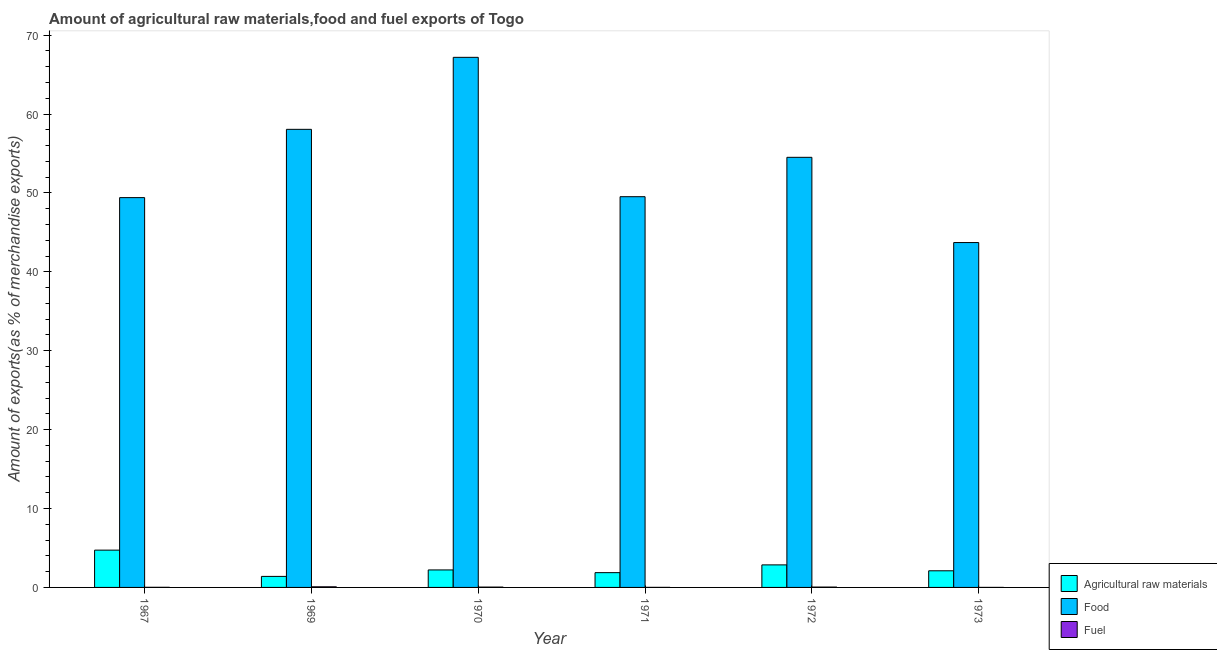How many different coloured bars are there?
Keep it short and to the point. 3. How many groups of bars are there?
Offer a very short reply. 6. How many bars are there on the 5th tick from the left?
Your answer should be compact. 3. What is the label of the 5th group of bars from the left?
Your answer should be very brief. 1972. What is the percentage of fuel exports in 1972?
Your response must be concise. 0.05. Across all years, what is the maximum percentage of fuel exports?
Your answer should be compact. 0.08. Across all years, what is the minimum percentage of fuel exports?
Make the answer very short. 0. In which year was the percentage of food exports maximum?
Your answer should be very brief. 1970. In which year was the percentage of food exports minimum?
Keep it short and to the point. 1973. What is the total percentage of raw materials exports in the graph?
Provide a short and direct response. 15.18. What is the difference between the percentage of fuel exports in 1969 and that in 1971?
Your response must be concise. 0.07. What is the difference between the percentage of food exports in 1972 and the percentage of raw materials exports in 1971?
Ensure brevity in your answer.  4.99. What is the average percentage of food exports per year?
Your answer should be compact. 53.74. In the year 1967, what is the difference between the percentage of food exports and percentage of fuel exports?
Ensure brevity in your answer.  0. What is the ratio of the percentage of fuel exports in 1967 to that in 1969?
Give a very brief answer. 0.2. Is the percentage of raw materials exports in 1970 less than that in 1973?
Give a very brief answer. No. Is the difference between the percentage of fuel exports in 1970 and 1972 greater than the difference between the percentage of food exports in 1970 and 1972?
Ensure brevity in your answer.  No. What is the difference between the highest and the second highest percentage of fuel exports?
Your answer should be very brief. 0.03. What is the difference between the highest and the lowest percentage of fuel exports?
Offer a very short reply. 0.07. Is the sum of the percentage of fuel exports in 1970 and 1973 greater than the maximum percentage of food exports across all years?
Offer a terse response. No. What does the 2nd bar from the left in 1970 represents?
Provide a succinct answer. Food. What does the 2nd bar from the right in 1967 represents?
Offer a terse response. Food. How many bars are there?
Your answer should be very brief. 18. What is the difference between two consecutive major ticks on the Y-axis?
Offer a very short reply. 10. Does the graph contain grids?
Provide a short and direct response. No. What is the title of the graph?
Make the answer very short. Amount of agricultural raw materials,food and fuel exports of Togo. Does "Wage workers" appear as one of the legend labels in the graph?
Make the answer very short. No. What is the label or title of the Y-axis?
Offer a terse response. Amount of exports(as % of merchandise exports). What is the Amount of exports(as % of merchandise exports) of Agricultural raw materials in 1967?
Offer a terse response. 4.73. What is the Amount of exports(as % of merchandise exports) of Food in 1967?
Provide a short and direct response. 49.41. What is the Amount of exports(as % of merchandise exports) in Fuel in 1967?
Provide a short and direct response. 0.02. What is the Amount of exports(as % of merchandise exports) of Agricultural raw materials in 1969?
Offer a terse response. 1.4. What is the Amount of exports(as % of merchandise exports) in Food in 1969?
Offer a terse response. 58.07. What is the Amount of exports(as % of merchandise exports) in Fuel in 1969?
Your answer should be very brief. 0.08. What is the Amount of exports(as % of merchandise exports) in Agricultural raw materials in 1970?
Give a very brief answer. 2.22. What is the Amount of exports(as % of merchandise exports) of Food in 1970?
Your response must be concise. 67.2. What is the Amount of exports(as % of merchandise exports) of Fuel in 1970?
Ensure brevity in your answer.  0.04. What is the Amount of exports(as % of merchandise exports) in Agricultural raw materials in 1971?
Ensure brevity in your answer.  1.87. What is the Amount of exports(as % of merchandise exports) in Food in 1971?
Provide a short and direct response. 49.53. What is the Amount of exports(as % of merchandise exports) of Fuel in 1971?
Provide a short and direct response. 0.01. What is the Amount of exports(as % of merchandise exports) of Agricultural raw materials in 1972?
Offer a terse response. 2.86. What is the Amount of exports(as % of merchandise exports) in Food in 1972?
Your answer should be very brief. 54.52. What is the Amount of exports(as % of merchandise exports) in Fuel in 1972?
Your response must be concise. 0.05. What is the Amount of exports(as % of merchandise exports) of Agricultural raw materials in 1973?
Your answer should be very brief. 2.11. What is the Amount of exports(as % of merchandise exports) of Food in 1973?
Your response must be concise. 43.72. What is the Amount of exports(as % of merchandise exports) of Fuel in 1973?
Your answer should be very brief. 0. Across all years, what is the maximum Amount of exports(as % of merchandise exports) of Agricultural raw materials?
Your answer should be very brief. 4.73. Across all years, what is the maximum Amount of exports(as % of merchandise exports) of Food?
Provide a succinct answer. 67.2. Across all years, what is the maximum Amount of exports(as % of merchandise exports) of Fuel?
Offer a very short reply. 0.08. Across all years, what is the minimum Amount of exports(as % of merchandise exports) of Agricultural raw materials?
Your response must be concise. 1.4. Across all years, what is the minimum Amount of exports(as % of merchandise exports) of Food?
Your answer should be compact. 43.72. Across all years, what is the minimum Amount of exports(as % of merchandise exports) of Fuel?
Your response must be concise. 0. What is the total Amount of exports(as % of merchandise exports) of Agricultural raw materials in the graph?
Provide a succinct answer. 15.18. What is the total Amount of exports(as % of merchandise exports) in Food in the graph?
Offer a terse response. 322.45. What is the total Amount of exports(as % of merchandise exports) in Fuel in the graph?
Provide a succinct answer. 0.19. What is the difference between the Amount of exports(as % of merchandise exports) of Agricultural raw materials in 1967 and that in 1969?
Ensure brevity in your answer.  3.33. What is the difference between the Amount of exports(as % of merchandise exports) in Food in 1967 and that in 1969?
Provide a short and direct response. -8.66. What is the difference between the Amount of exports(as % of merchandise exports) in Fuel in 1967 and that in 1969?
Offer a terse response. -0.06. What is the difference between the Amount of exports(as % of merchandise exports) in Agricultural raw materials in 1967 and that in 1970?
Your answer should be very brief. 2.51. What is the difference between the Amount of exports(as % of merchandise exports) of Food in 1967 and that in 1970?
Offer a terse response. -17.78. What is the difference between the Amount of exports(as % of merchandise exports) in Fuel in 1967 and that in 1970?
Offer a very short reply. -0.03. What is the difference between the Amount of exports(as % of merchandise exports) in Agricultural raw materials in 1967 and that in 1971?
Your answer should be very brief. 2.85. What is the difference between the Amount of exports(as % of merchandise exports) of Food in 1967 and that in 1971?
Provide a succinct answer. -0.12. What is the difference between the Amount of exports(as % of merchandise exports) in Fuel in 1967 and that in 1971?
Ensure brevity in your answer.  0.01. What is the difference between the Amount of exports(as % of merchandise exports) of Agricultural raw materials in 1967 and that in 1972?
Offer a terse response. 1.87. What is the difference between the Amount of exports(as % of merchandise exports) of Food in 1967 and that in 1972?
Keep it short and to the point. -5.11. What is the difference between the Amount of exports(as % of merchandise exports) in Fuel in 1967 and that in 1972?
Ensure brevity in your answer.  -0.03. What is the difference between the Amount of exports(as % of merchandise exports) of Agricultural raw materials in 1967 and that in 1973?
Your answer should be very brief. 2.62. What is the difference between the Amount of exports(as % of merchandise exports) of Food in 1967 and that in 1973?
Your answer should be very brief. 5.7. What is the difference between the Amount of exports(as % of merchandise exports) of Fuel in 1967 and that in 1973?
Give a very brief answer. 0.01. What is the difference between the Amount of exports(as % of merchandise exports) of Agricultural raw materials in 1969 and that in 1970?
Your response must be concise. -0.82. What is the difference between the Amount of exports(as % of merchandise exports) in Food in 1969 and that in 1970?
Give a very brief answer. -9.13. What is the difference between the Amount of exports(as % of merchandise exports) in Fuel in 1969 and that in 1970?
Provide a short and direct response. 0.04. What is the difference between the Amount of exports(as % of merchandise exports) of Agricultural raw materials in 1969 and that in 1971?
Provide a short and direct response. -0.48. What is the difference between the Amount of exports(as % of merchandise exports) in Food in 1969 and that in 1971?
Your answer should be very brief. 8.54. What is the difference between the Amount of exports(as % of merchandise exports) of Fuel in 1969 and that in 1971?
Keep it short and to the point. 0.07. What is the difference between the Amount of exports(as % of merchandise exports) in Agricultural raw materials in 1969 and that in 1972?
Keep it short and to the point. -1.46. What is the difference between the Amount of exports(as % of merchandise exports) in Food in 1969 and that in 1972?
Give a very brief answer. 3.55. What is the difference between the Amount of exports(as % of merchandise exports) of Fuel in 1969 and that in 1972?
Ensure brevity in your answer.  0.03. What is the difference between the Amount of exports(as % of merchandise exports) in Agricultural raw materials in 1969 and that in 1973?
Offer a very short reply. -0.71. What is the difference between the Amount of exports(as % of merchandise exports) in Food in 1969 and that in 1973?
Offer a very short reply. 14.35. What is the difference between the Amount of exports(as % of merchandise exports) in Fuel in 1969 and that in 1973?
Offer a very short reply. 0.07. What is the difference between the Amount of exports(as % of merchandise exports) of Agricultural raw materials in 1970 and that in 1971?
Make the answer very short. 0.34. What is the difference between the Amount of exports(as % of merchandise exports) of Food in 1970 and that in 1971?
Provide a succinct answer. 17.67. What is the difference between the Amount of exports(as % of merchandise exports) in Fuel in 1970 and that in 1971?
Provide a short and direct response. 0.03. What is the difference between the Amount of exports(as % of merchandise exports) of Agricultural raw materials in 1970 and that in 1972?
Make the answer very short. -0.64. What is the difference between the Amount of exports(as % of merchandise exports) in Food in 1970 and that in 1972?
Give a very brief answer. 12.68. What is the difference between the Amount of exports(as % of merchandise exports) of Fuel in 1970 and that in 1972?
Keep it short and to the point. -0. What is the difference between the Amount of exports(as % of merchandise exports) in Agricultural raw materials in 1970 and that in 1973?
Ensure brevity in your answer.  0.11. What is the difference between the Amount of exports(as % of merchandise exports) in Food in 1970 and that in 1973?
Provide a short and direct response. 23.48. What is the difference between the Amount of exports(as % of merchandise exports) of Fuel in 1970 and that in 1973?
Your answer should be compact. 0.04. What is the difference between the Amount of exports(as % of merchandise exports) of Agricultural raw materials in 1971 and that in 1972?
Offer a terse response. -0.98. What is the difference between the Amount of exports(as % of merchandise exports) in Food in 1971 and that in 1972?
Your answer should be very brief. -4.99. What is the difference between the Amount of exports(as % of merchandise exports) of Fuel in 1971 and that in 1972?
Make the answer very short. -0.04. What is the difference between the Amount of exports(as % of merchandise exports) of Agricultural raw materials in 1971 and that in 1973?
Your response must be concise. -0.24. What is the difference between the Amount of exports(as % of merchandise exports) in Food in 1971 and that in 1973?
Offer a very short reply. 5.81. What is the difference between the Amount of exports(as % of merchandise exports) in Fuel in 1971 and that in 1973?
Your answer should be very brief. 0. What is the difference between the Amount of exports(as % of merchandise exports) of Agricultural raw materials in 1972 and that in 1973?
Offer a very short reply. 0.75. What is the difference between the Amount of exports(as % of merchandise exports) of Food in 1972 and that in 1973?
Offer a terse response. 10.8. What is the difference between the Amount of exports(as % of merchandise exports) of Fuel in 1972 and that in 1973?
Provide a succinct answer. 0.04. What is the difference between the Amount of exports(as % of merchandise exports) of Agricultural raw materials in 1967 and the Amount of exports(as % of merchandise exports) of Food in 1969?
Your answer should be very brief. -53.34. What is the difference between the Amount of exports(as % of merchandise exports) of Agricultural raw materials in 1967 and the Amount of exports(as % of merchandise exports) of Fuel in 1969?
Your answer should be compact. 4.65. What is the difference between the Amount of exports(as % of merchandise exports) of Food in 1967 and the Amount of exports(as % of merchandise exports) of Fuel in 1969?
Your response must be concise. 49.33. What is the difference between the Amount of exports(as % of merchandise exports) in Agricultural raw materials in 1967 and the Amount of exports(as % of merchandise exports) in Food in 1970?
Keep it short and to the point. -62.47. What is the difference between the Amount of exports(as % of merchandise exports) of Agricultural raw materials in 1967 and the Amount of exports(as % of merchandise exports) of Fuel in 1970?
Provide a succinct answer. 4.68. What is the difference between the Amount of exports(as % of merchandise exports) of Food in 1967 and the Amount of exports(as % of merchandise exports) of Fuel in 1970?
Make the answer very short. 49.37. What is the difference between the Amount of exports(as % of merchandise exports) in Agricultural raw materials in 1967 and the Amount of exports(as % of merchandise exports) in Food in 1971?
Your response must be concise. -44.8. What is the difference between the Amount of exports(as % of merchandise exports) in Agricultural raw materials in 1967 and the Amount of exports(as % of merchandise exports) in Fuel in 1971?
Offer a terse response. 4.72. What is the difference between the Amount of exports(as % of merchandise exports) of Food in 1967 and the Amount of exports(as % of merchandise exports) of Fuel in 1971?
Offer a very short reply. 49.41. What is the difference between the Amount of exports(as % of merchandise exports) in Agricultural raw materials in 1967 and the Amount of exports(as % of merchandise exports) in Food in 1972?
Offer a terse response. -49.79. What is the difference between the Amount of exports(as % of merchandise exports) of Agricultural raw materials in 1967 and the Amount of exports(as % of merchandise exports) of Fuel in 1972?
Offer a very short reply. 4.68. What is the difference between the Amount of exports(as % of merchandise exports) in Food in 1967 and the Amount of exports(as % of merchandise exports) in Fuel in 1972?
Offer a very short reply. 49.37. What is the difference between the Amount of exports(as % of merchandise exports) in Agricultural raw materials in 1967 and the Amount of exports(as % of merchandise exports) in Food in 1973?
Make the answer very short. -38.99. What is the difference between the Amount of exports(as % of merchandise exports) in Agricultural raw materials in 1967 and the Amount of exports(as % of merchandise exports) in Fuel in 1973?
Your answer should be very brief. 4.72. What is the difference between the Amount of exports(as % of merchandise exports) of Food in 1967 and the Amount of exports(as % of merchandise exports) of Fuel in 1973?
Your answer should be compact. 49.41. What is the difference between the Amount of exports(as % of merchandise exports) of Agricultural raw materials in 1969 and the Amount of exports(as % of merchandise exports) of Food in 1970?
Provide a short and direct response. -65.8. What is the difference between the Amount of exports(as % of merchandise exports) of Agricultural raw materials in 1969 and the Amount of exports(as % of merchandise exports) of Fuel in 1970?
Make the answer very short. 1.35. What is the difference between the Amount of exports(as % of merchandise exports) in Food in 1969 and the Amount of exports(as % of merchandise exports) in Fuel in 1970?
Make the answer very short. 58.03. What is the difference between the Amount of exports(as % of merchandise exports) in Agricultural raw materials in 1969 and the Amount of exports(as % of merchandise exports) in Food in 1971?
Keep it short and to the point. -48.13. What is the difference between the Amount of exports(as % of merchandise exports) of Agricultural raw materials in 1969 and the Amount of exports(as % of merchandise exports) of Fuel in 1971?
Your answer should be compact. 1.39. What is the difference between the Amount of exports(as % of merchandise exports) in Food in 1969 and the Amount of exports(as % of merchandise exports) in Fuel in 1971?
Your response must be concise. 58.06. What is the difference between the Amount of exports(as % of merchandise exports) in Agricultural raw materials in 1969 and the Amount of exports(as % of merchandise exports) in Food in 1972?
Your answer should be compact. -53.12. What is the difference between the Amount of exports(as % of merchandise exports) of Agricultural raw materials in 1969 and the Amount of exports(as % of merchandise exports) of Fuel in 1972?
Offer a terse response. 1.35. What is the difference between the Amount of exports(as % of merchandise exports) in Food in 1969 and the Amount of exports(as % of merchandise exports) in Fuel in 1972?
Provide a succinct answer. 58.02. What is the difference between the Amount of exports(as % of merchandise exports) of Agricultural raw materials in 1969 and the Amount of exports(as % of merchandise exports) of Food in 1973?
Offer a very short reply. -42.32. What is the difference between the Amount of exports(as % of merchandise exports) in Agricultural raw materials in 1969 and the Amount of exports(as % of merchandise exports) in Fuel in 1973?
Keep it short and to the point. 1.39. What is the difference between the Amount of exports(as % of merchandise exports) of Food in 1969 and the Amount of exports(as % of merchandise exports) of Fuel in 1973?
Make the answer very short. 58.07. What is the difference between the Amount of exports(as % of merchandise exports) of Agricultural raw materials in 1970 and the Amount of exports(as % of merchandise exports) of Food in 1971?
Your answer should be compact. -47.31. What is the difference between the Amount of exports(as % of merchandise exports) of Agricultural raw materials in 1970 and the Amount of exports(as % of merchandise exports) of Fuel in 1971?
Keep it short and to the point. 2.21. What is the difference between the Amount of exports(as % of merchandise exports) of Food in 1970 and the Amount of exports(as % of merchandise exports) of Fuel in 1971?
Provide a succinct answer. 67.19. What is the difference between the Amount of exports(as % of merchandise exports) of Agricultural raw materials in 1970 and the Amount of exports(as % of merchandise exports) of Food in 1972?
Give a very brief answer. -52.3. What is the difference between the Amount of exports(as % of merchandise exports) of Agricultural raw materials in 1970 and the Amount of exports(as % of merchandise exports) of Fuel in 1972?
Keep it short and to the point. 2.17. What is the difference between the Amount of exports(as % of merchandise exports) of Food in 1970 and the Amount of exports(as % of merchandise exports) of Fuel in 1972?
Ensure brevity in your answer.  67.15. What is the difference between the Amount of exports(as % of merchandise exports) in Agricultural raw materials in 1970 and the Amount of exports(as % of merchandise exports) in Food in 1973?
Provide a succinct answer. -41.5. What is the difference between the Amount of exports(as % of merchandise exports) in Agricultural raw materials in 1970 and the Amount of exports(as % of merchandise exports) in Fuel in 1973?
Keep it short and to the point. 2.21. What is the difference between the Amount of exports(as % of merchandise exports) in Food in 1970 and the Amount of exports(as % of merchandise exports) in Fuel in 1973?
Ensure brevity in your answer.  67.19. What is the difference between the Amount of exports(as % of merchandise exports) of Agricultural raw materials in 1971 and the Amount of exports(as % of merchandise exports) of Food in 1972?
Offer a terse response. -52.65. What is the difference between the Amount of exports(as % of merchandise exports) in Agricultural raw materials in 1971 and the Amount of exports(as % of merchandise exports) in Fuel in 1972?
Make the answer very short. 1.83. What is the difference between the Amount of exports(as % of merchandise exports) in Food in 1971 and the Amount of exports(as % of merchandise exports) in Fuel in 1972?
Offer a terse response. 49.49. What is the difference between the Amount of exports(as % of merchandise exports) in Agricultural raw materials in 1971 and the Amount of exports(as % of merchandise exports) in Food in 1973?
Offer a very short reply. -41.84. What is the difference between the Amount of exports(as % of merchandise exports) in Agricultural raw materials in 1971 and the Amount of exports(as % of merchandise exports) in Fuel in 1973?
Make the answer very short. 1.87. What is the difference between the Amount of exports(as % of merchandise exports) of Food in 1971 and the Amount of exports(as % of merchandise exports) of Fuel in 1973?
Give a very brief answer. 49.53. What is the difference between the Amount of exports(as % of merchandise exports) in Agricultural raw materials in 1972 and the Amount of exports(as % of merchandise exports) in Food in 1973?
Make the answer very short. -40.86. What is the difference between the Amount of exports(as % of merchandise exports) in Agricultural raw materials in 1972 and the Amount of exports(as % of merchandise exports) in Fuel in 1973?
Your answer should be very brief. 2.85. What is the difference between the Amount of exports(as % of merchandise exports) of Food in 1972 and the Amount of exports(as % of merchandise exports) of Fuel in 1973?
Provide a short and direct response. 54.52. What is the average Amount of exports(as % of merchandise exports) of Agricultural raw materials per year?
Provide a succinct answer. 2.53. What is the average Amount of exports(as % of merchandise exports) in Food per year?
Your answer should be compact. 53.74. What is the average Amount of exports(as % of merchandise exports) of Fuel per year?
Your response must be concise. 0.03. In the year 1967, what is the difference between the Amount of exports(as % of merchandise exports) in Agricultural raw materials and Amount of exports(as % of merchandise exports) in Food?
Your answer should be very brief. -44.69. In the year 1967, what is the difference between the Amount of exports(as % of merchandise exports) of Agricultural raw materials and Amount of exports(as % of merchandise exports) of Fuel?
Offer a terse response. 4.71. In the year 1967, what is the difference between the Amount of exports(as % of merchandise exports) in Food and Amount of exports(as % of merchandise exports) in Fuel?
Provide a short and direct response. 49.4. In the year 1969, what is the difference between the Amount of exports(as % of merchandise exports) of Agricultural raw materials and Amount of exports(as % of merchandise exports) of Food?
Provide a succinct answer. -56.67. In the year 1969, what is the difference between the Amount of exports(as % of merchandise exports) in Agricultural raw materials and Amount of exports(as % of merchandise exports) in Fuel?
Provide a short and direct response. 1.32. In the year 1969, what is the difference between the Amount of exports(as % of merchandise exports) in Food and Amount of exports(as % of merchandise exports) in Fuel?
Make the answer very short. 57.99. In the year 1970, what is the difference between the Amount of exports(as % of merchandise exports) of Agricultural raw materials and Amount of exports(as % of merchandise exports) of Food?
Your answer should be compact. -64.98. In the year 1970, what is the difference between the Amount of exports(as % of merchandise exports) in Agricultural raw materials and Amount of exports(as % of merchandise exports) in Fuel?
Provide a succinct answer. 2.18. In the year 1970, what is the difference between the Amount of exports(as % of merchandise exports) of Food and Amount of exports(as % of merchandise exports) of Fuel?
Provide a short and direct response. 67.15. In the year 1971, what is the difference between the Amount of exports(as % of merchandise exports) of Agricultural raw materials and Amount of exports(as % of merchandise exports) of Food?
Offer a terse response. -47.66. In the year 1971, what is the difference between the Amount of exports(as % of merchandise exports) in Agricultural raw materials and Amount of exports(as % of merchandise exports) in Fuel?
Provide a short and direct response. 1.87. In the year 1971, what is the difference between the Amount of exports(as % of merchandise exports) of Food and Amount of exports(as % of merchandise exports) of Fuel?
Ensure brevity in your answer.  49.52. In the year 1972, what is the difference between the Amount of exports(as % of merchandise exports) of Agricultural raw materials and Amount of exports(as % of merchandise exports) of Food?
Keep it short and to the point. -51.66. In the year 1972, what is the difference between the Amount of exports(as % of merchandise exports) in Agricultural raw materials and Amount of exports(as % of merchandise exports) in Fuel?
Give a very brief answer. 2.81. In the year 1972, what is the difference between the Amount of exports(as % of merchandise exports) of Food and Amount of exports(as % of merchandise exports) of Fuel?
Provide a succinct answer. 54.48. In the year 1973, what is the difference between the Amount of exports(as % of merchandise exports) of Agricultural raw materials and Amount of exports(as % of merchandise exports) of Food?
Keep it short and to the point. -41.61. In the year 1973, what is the difference between the Amount of exports(as % of merchandise exports) in Agricultural raw materials and Amount of exports(as % of merchandise exports) in Fuel?
Offer a terse response. 2.1. In the year 1973, what is the difference between the Amount of exports(as % of merchandise exports) of Food and Amount of exports(as % of merchandise exports) of Fuel?
Your answer should be very brief. 43.71. What is the ratio of the Amount of exports(as % of merchandise exports) of Agricultural raw materials in 1967 to that in 1969?
Provide a short and direct response. 3.38. What is the ratio of the Amount of exports(as % of merchandise exports) of Food in 1967 to that in 1969?
Offer a very short reply. 0.85. What is the ratio of the Amount of exports(as % of merchandise exports) in Fuel in 1967 to that in 1969?
Your answer should be compact. 0.2. What is the ratio of the Amount of exports(as % of merchandise exports) of Agricultural raw materials in 1967 to that in 1970?
Provide a short and direct response. 2.13. What is the ratio of the Amount of exports(as % of merchandise exports) of Food in 1967 to that in 1970?
Ensure brevity in your answer.  0.74. What is the ratio of the Amount of exports(as % of merchandise exports) in Fuel in 1967 to that in 1970?
Your answer should be compact. 0.38. What is the ratio of the Amount of exports(as % of merchandise exports) in Agricultural raw materials in 1967 to that in 1971?
Make the answer very short. 2.52. What is the ratio of the Amount of exports(as % of merchandise exports) in Fuel in 1967 to that in 1971?
Your answer should be very brief. 2.11. What is the ratio of the Amount of exports(as % of merchandise exports) of Agricultural raw materials in 1967 to that in 1972?
Make the answer very short. 1.65. What is the ratio of the Amount of exports(as % of merchandise exports) in Food in 1967 to that in 1972?
Keep it short and to the point. 0.91. What is the ratio of the Amount of exports(as % of merchandise exports) of Fuel in 1967 to that in 1972?
Keep it short and to the point. 0.35. What is the ratio of the Amount of exports(as % of merchandise exports) of Agricultural raw materials in 1967 to that in 1973?
Your answer should be compact. 2.24. What is the ratio of the Amount of exports(as % of merchandise exports) in Food in 1967 to that in 1973?
Give a very brief answer. 1.13. What is the ratio of the Amount of exports(as % of merchandise exports) of Fuel in 1967 to that in 1973?
Make the answer very short. 3.7. What is the ratio of the Amount of exports(as % of merchandise exports) of Agricultural raw materials in 1969 to that in 1970?
Give a very brief answer. 0.63. What is the ratio of the Amount of exports(as % of merchandise exports) in Food in 1969 to that in 1970?
Offer a very short reply. 0.86. What is the ratio of the Amount of exports(as % of merchandise exports) of Fuel in 1969 to that in 1970?
Keep it short and to the point. 1.86. What is the ratio of the Amount of exports(as % of merchandise exports) in Agricultural raw materials in 1969 to that in 1971?
Your answer should be very brief. 0.75. What is the ratio of the Amount of exports(as % of merchandise exports) of Food in 1969 to that in 1971?
Your answer should be very brief. 1.17. What is the ratio of the Amount of exports(as % of merchandise exports) of Fuel in 1969 to that in 1971?
Give a very brief answer. 10.44. What is the ratio of the Amount of exports(as % of merchandise exports) in Agricultural raw materials in 1969 to that in 1972?
Offer a very short reply. 0.49. What is the ratio of the Amount of exports(as % of merchandise exports) of Food in 1969 to that in 1972?
Offer a very short reply. 1.07. What is the ratio of the Amount of exports(as % of merchandise exports) in Fuel in 1969 to that in 1972?
Provide a short and direct response. 1.73. What is the ratio of the Amount of exports(as % of merchandise exports) in Agricultural raw materials in 1969 to that in 1973?
Provide a succinct answer. 0.66. What is the ratio of the Amount of exports(as % of merchandise exports) of Food in 1969 to that in 1973?
Offer a terse response. 1.33. What is the ratio of the Amount of exports(as % of merchandise exports) of Fuel in 1969 to that in 1973?
Provide a succinct answer. 18.28. What is the ratio of the Amount of exports(as % of merchandise exports) in Agricultural raw materials in 1970 to that in 1971?
Make the answer very short. 1.18. What is the ratio of the Amount of exports(as % of merchandise exports) of Food in 1970 to that in 1971?
Your response must be concise. 1.36. What is the ratio of the Amount of exports(as % of merchandise exports) in Fuel in 1970 to that in 1971?
Offer a very short reply. 5.61. What is the ratio of the Amount of exports(as % of merchandise exports) of Agricultural raw materials in 1970 to that in 1972?
Keep it short and to the point. 0.78. What is the ratio of the Amount of exports(as % of merchandise exports) in Food in 1970 to that in 1972?
Ensure brevity in your answer.  1.23. What is the ratio of the Amount of exports(as % of merchandise exports) of Fuel in 1970 to that in 1972?
Your answer should be very brief. 0.93. What is the ratio of the Amount of exports(as % of merchandise exports) in Agricultural raw materials in 1970 to that in 1973?
Keep it short and to the point. 1.05. What is the ratio of the Amount of exports(as % of merchandise exports) of Food in 1970 to that in 1973?
Provide a short and direct response. 1.54. What is the ratio of the Amount of exports(as % of merchandise exports) of Fuel in 1970 to that in 1973?
Your answer should be compact. 9.83. What is the ratio of the Amount of exports(as % of merchandise exports) in Agricultural raw materials in 1971 to that in 1972?
Your answer should be very brief. 0.66. What is the ratio of the Amount of exports(as % of merchandise exports) of Food in 1971 to that in 1972?
Your answer should be compact. 0.91. What is the ratio of the Amount of exports(as % of merchandise exports) of Fuel in 1971 to that in 1972?
Your answer should be very brief. 0.17. What is the ratio of the Amount of exports(as % of merchandise exports) in Agricultural raw materials in 1971 to that in 1973?
Offer a terse response. 0.89. What is the ratio of the Amount of exports(as % of merchandise exports) in Food in 1971 to that in 1973?
Your answer should be very brief. 1.13. What is the ratio of the Amount of exports(as % of merchandise exports) in Fuel in 1971 to that in 1973?
Your answer should be very brief. 1.75. What is the ratio of the Amount of exports(as % of merchandise exports) in Agricultural raw materials in 1972 to that in 1973?
Offer a very short reply. 1.35. What is the ratio of the Amount of exports(as % of merchandise exports) of Food in 1972 to that in 1973?
Your response must be concise. 1.25. What is the ratio of the Amount of exports(as % of merchandise exports) in Fuel in 1972 to that in 1973?
Provide a succinct answer. 10.57. What is the difference between the highest and the second highest Amount of exports(as % of merchandise exports) of Agricultural raw materials?
Make the answer very short. 1.87. What is the difference between the highest and the second highest Amount of exports(as % of merchandise exports) of Food?
Keep it short and to the point. 9.13. What is the difference between the highest and the second highest Amount of exports(as % of merchandise exports) in Fuel?
Ensure brevity in your answer.  0.03. What is the difference between the highest and the lowest Amount of exports(as % of merchandise exports) of Agricultural raw materials?
Your response must be concise. 3.33. What is the difference between the highest and the lowest Amount of exports(as % of merchandise exports) of Food?
Your answer should be very brief. 23.48. What is the difference between the highest and the lowest Amount of exports(as % of merchandise exports) of Fuel?
Your response must be concise. 0.07. 